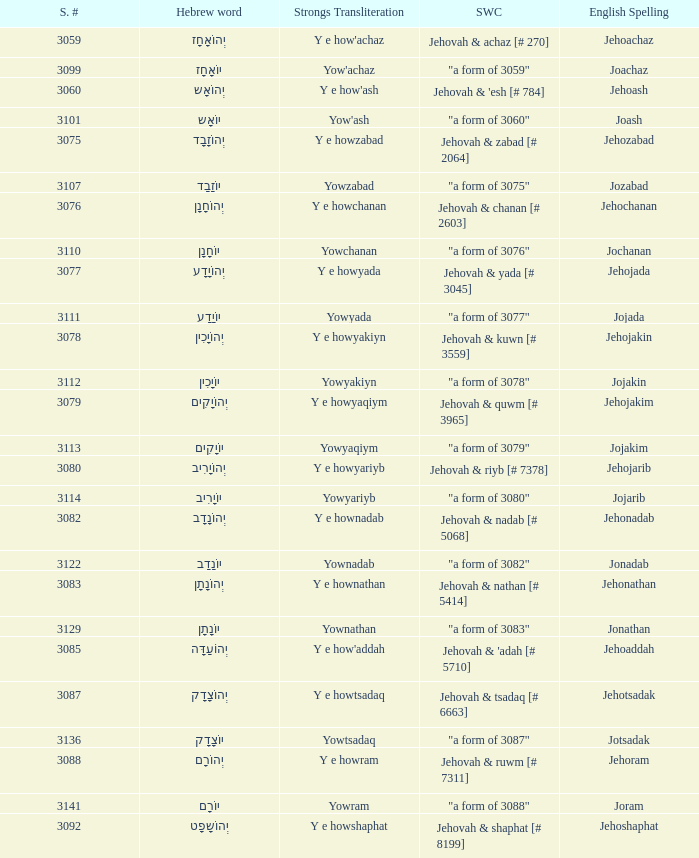What is the strongs transliteration of the hebrew word יוֹחָנָן? Yowchanan. 